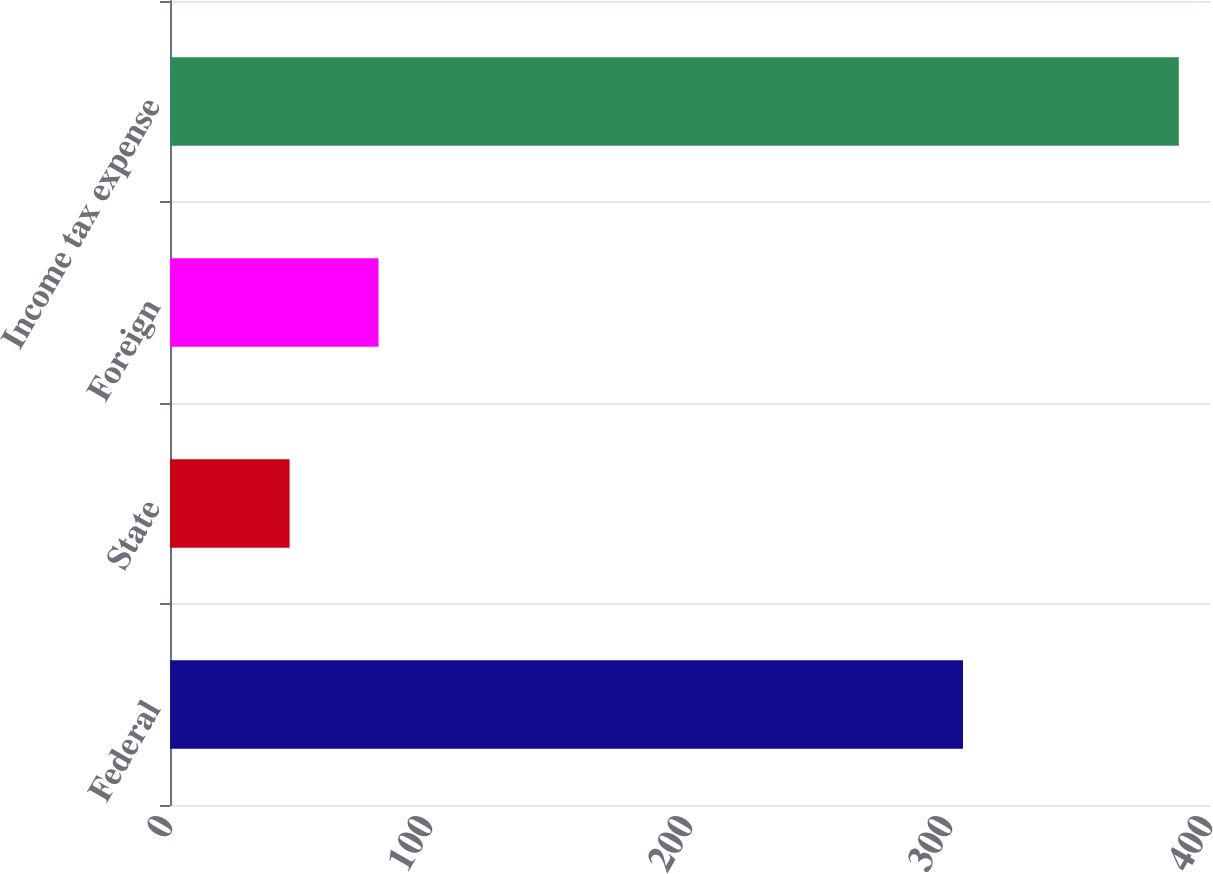Convert chart to OTSL. <chart><loc_0><loc_0><loc_500><loc_500><bar_chart><fcel>Federal<fcel>State<fcel>Foreign<fcel>Income tax expense<nl><fcel>305<fcel>46<fcel>80.2<fcel>388<nl></chart> 